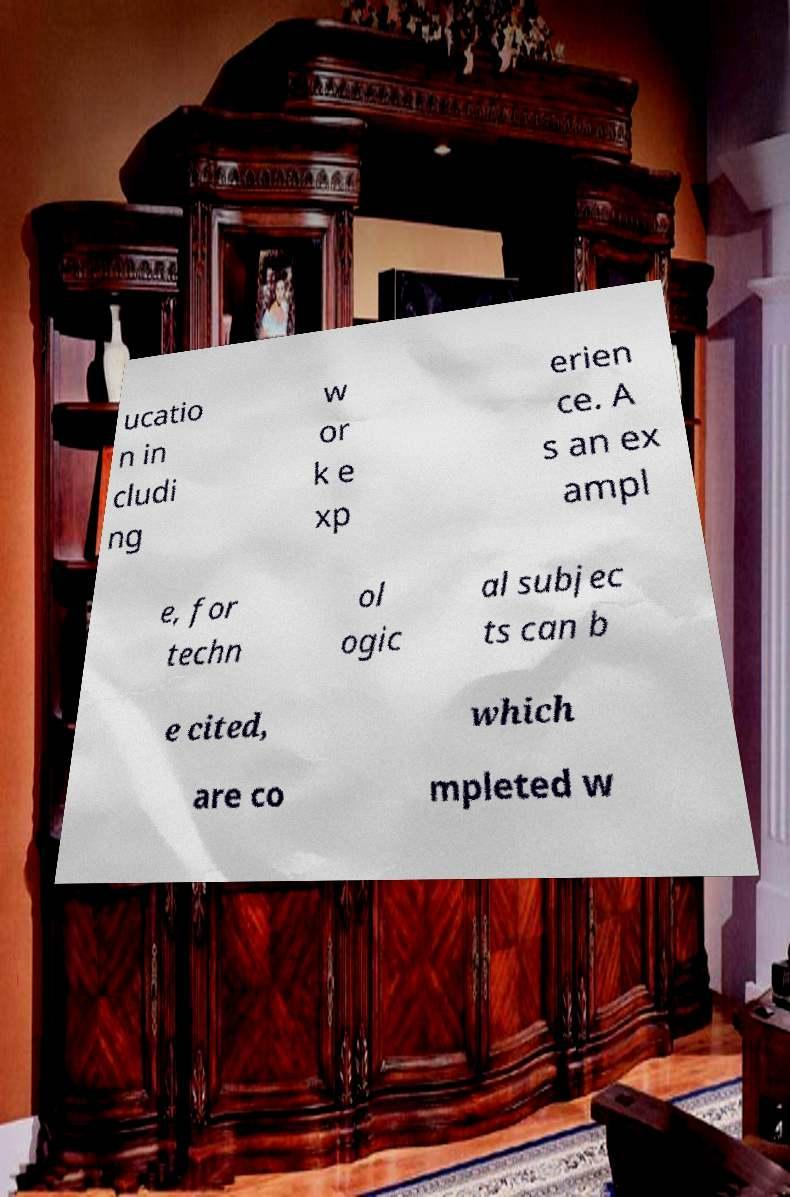Please identify and transcribe the text found in this image. ucatio n in cludi ng w or k e xp erien ce. A s an ex ampl e, for techn ol ogic al subjec ts can b e cited, which are co mpleted w 